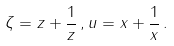<formula> <loc_0><loc_0><loc_500><loc_500>\zeta = z + \frac { 1 } { z } \, , u = x + \frac { 1 } { x } \, .</formula> 